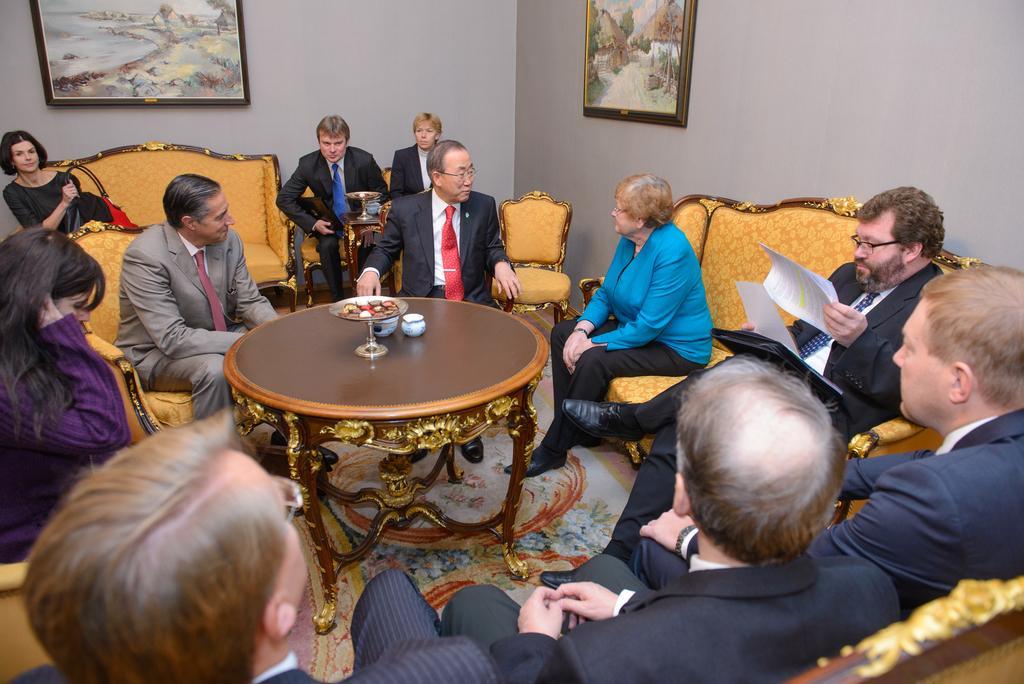Please provide a concise description of this image. Here we can see some persons are sitting on the sofas. He is holding a paper with his hand. He has spectacles. There is a table and this is floor. On the background there is a wall and these are the frames. 